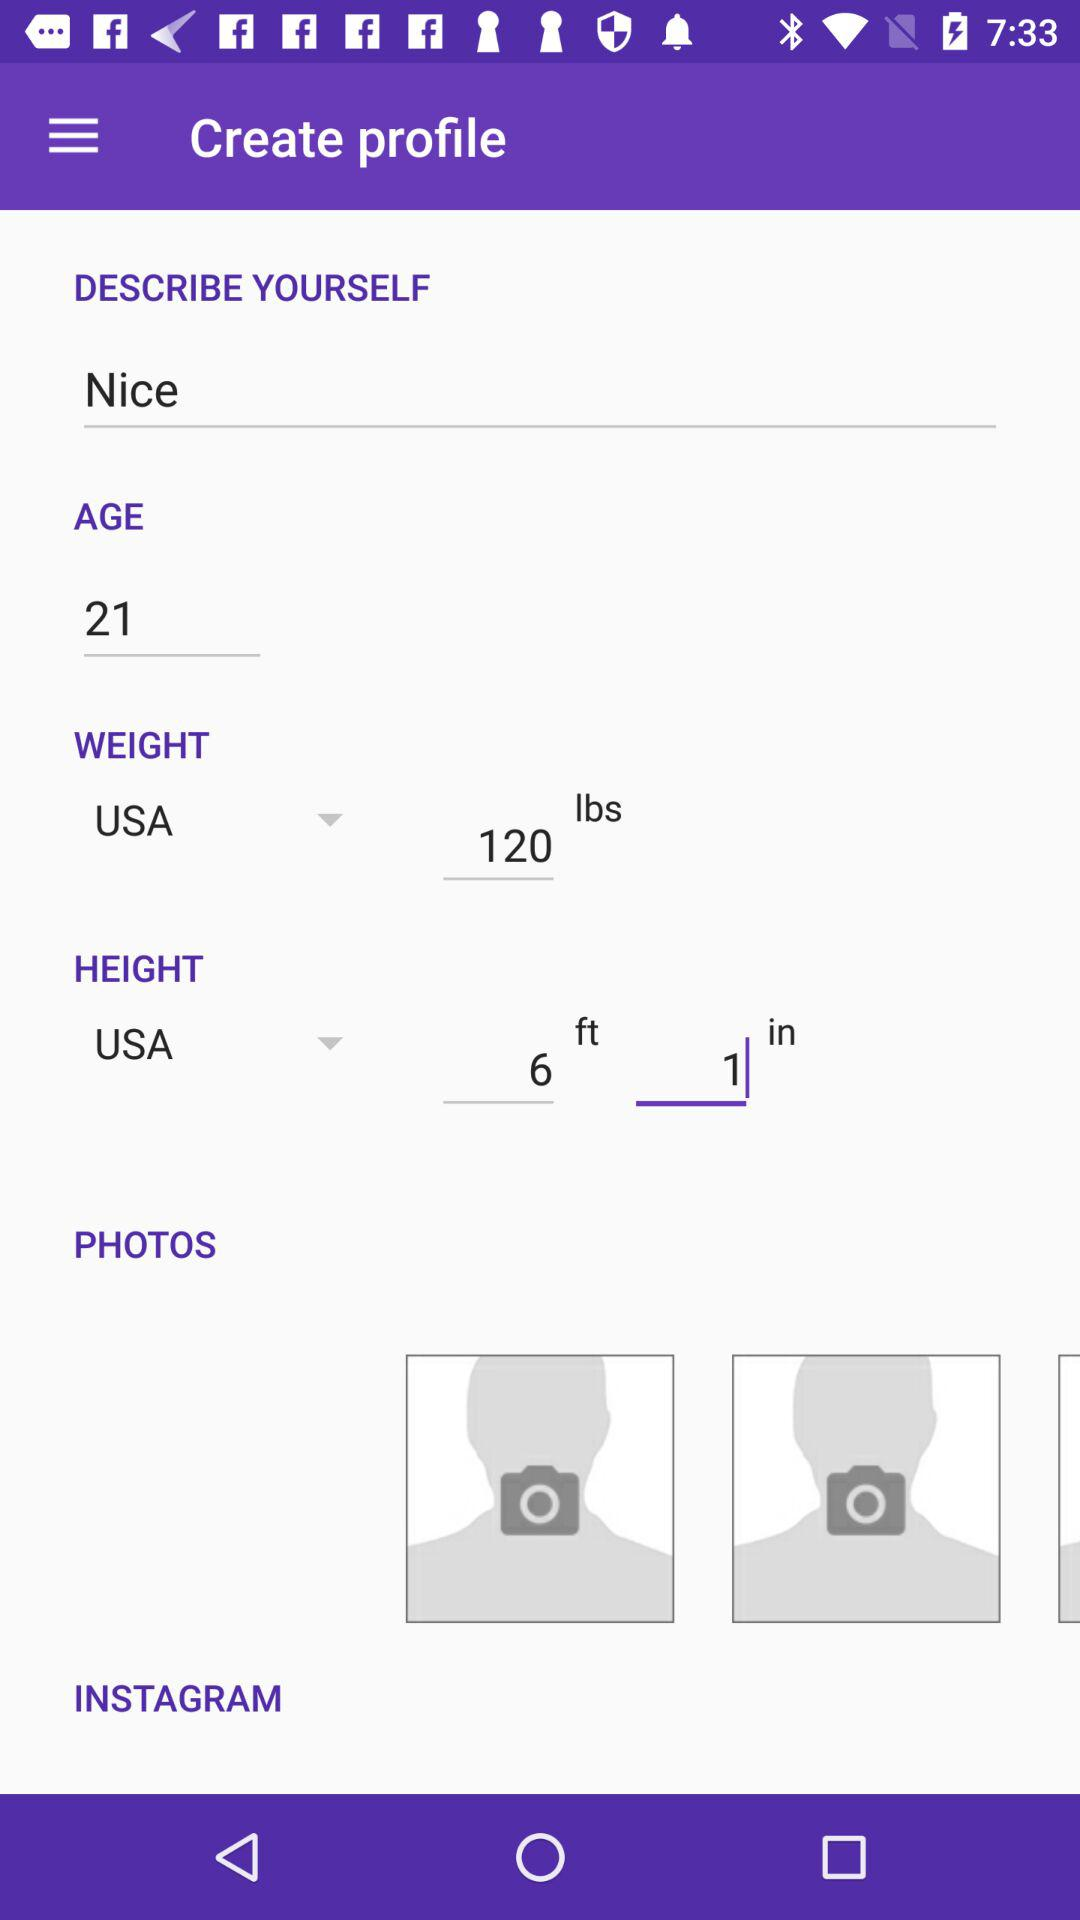What is written in "DESCRIBE YOURSELF"? In "DESCRIBE YOURSELF", "Nice" is written. 